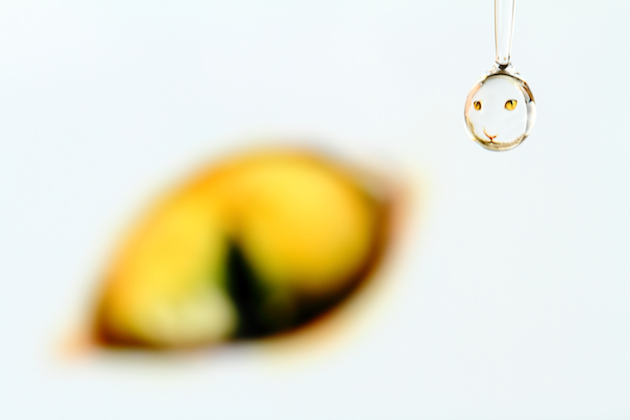Is the quality of the image good? Assessing whether an image is of good quality involves examining factors like focus, clarity, color balance, and composition. This particular image appears to have a deliberate shallow depth of field, with the background blurred to draw attention to the water droplet. The quality in terms of artistic expression and technical execution seems high, though for certain uses, one might prefer a different focal point or additional context. 